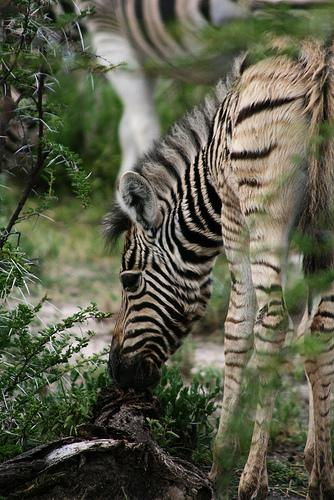Question: who is in the photo?
Choices:
A. A little girl.
B. A zebra.
C. A young couple.
D. A brown dog.
Answer with the letter. Answer: B Question: when was the photo taken?
Choices:
A. During the night.
B. In the office.
C. While running.
D. During the day.
Answer with the letter. Answer: D Question: what in the background?
Choices:
A. Mountains.
B. A tree.
C. Audience.
D. Park.
Answer with the letter. Answer: B 